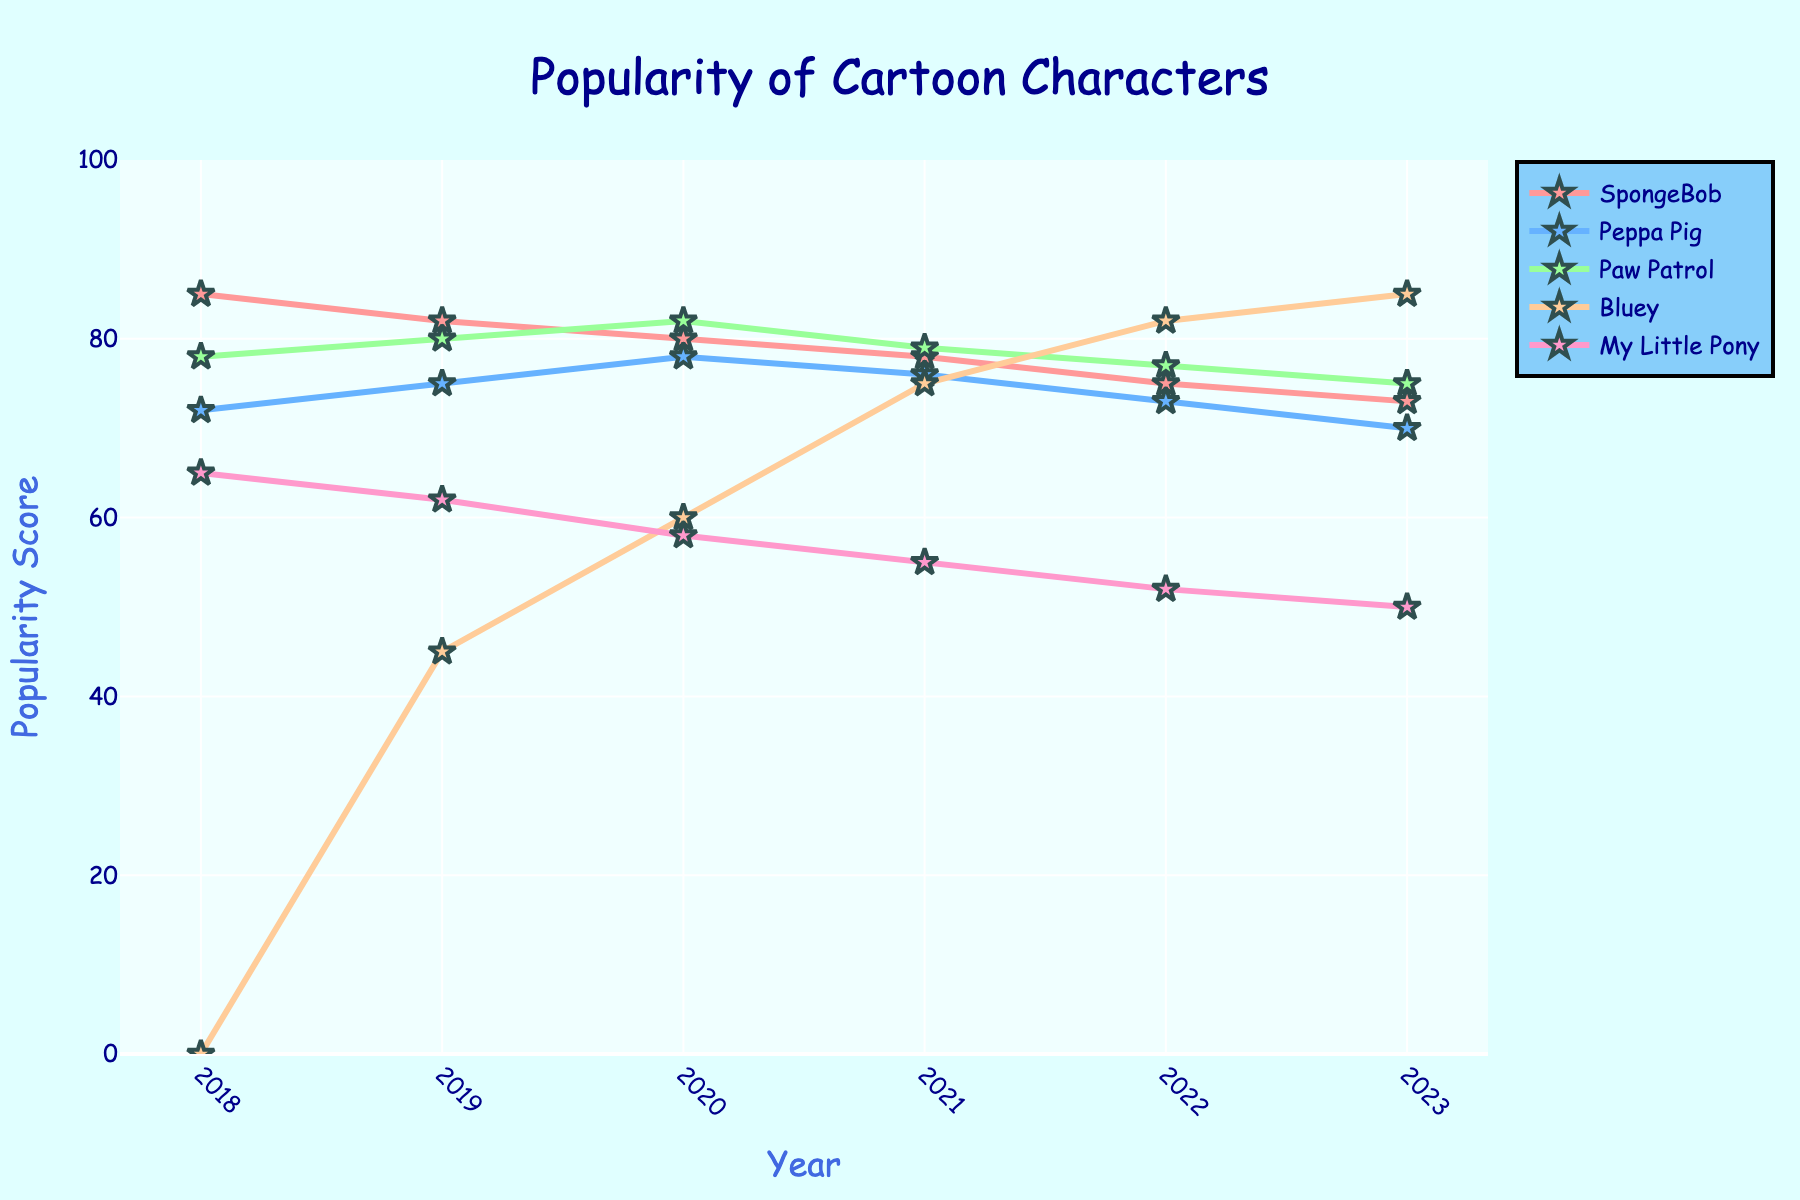What is the most popular cartoon character in 2023? Look at the data points for the year 2023 across all characters. The highest popularity score for 2023 is for Bluey, with a score of 85.
Answer: Bluey Which cartoon character has the largest decrease in popularity from 2018 to 2023? Calculate the difference in popularity scores between 2018 and 2023 for each character: SpongeBob (85 to 73, decrease of 12), Peppa Pig (72 to 70, decrease of 2), Paw Patrol (78 to 75, decrease of 3), Bluey (0 to 85, increase of 85), My Little Pony (65 to 50, decrease of 15). The largest decrease is for My Little Pony.
Answer: My Little Pony What is the trend observed for Bluey's popularity from 2018 to 2023? Since Bluey's popularity score starts at 0 in 2018 and increases consistently up to 85 in 2023, it shows a rising trend.
Answer: Rising trend In which year did SpongeBob and Paw Patrol have the closest popularity scores? Compare the differences in popularity scores for each year. In 2022, SpongeBob has a score of 75 and Paw Patrol has 77, with the smallest difference of 2.
Answer: 2022 Describe the change in popularity for My Little Pony between 2020 and 2023. The popularity score for My Little Pony decreased from 58 in 2020 to 50 in 2023.
Answer: Decreased Out of all the characters, which one has the second highest popularity in 2020? Identify the popularity scores for 2020 and find the second highest: SpongeBob (80), Peppa Pig (78), Paw Patrol (82), Bluey (60), My Little Pony (58). The second highest score is 80 for SpongeBob.
Answer: SpongeBob Which cartoon character shows the least variation in popularity over the years? Calculate the range (maximum score - minimum score) for each character. SpongeBob (85-73 = 12), Peppa Pig (78-70 = 8), Paw Patrol (82-75 = 7), Bluey (85-0 = 85), My Little Pony (65-50 = 15). Paw Patrol has the least variation with a range of 7.
Answer: Paw Patrol Between 2018 and 2019, which cartoon character experienced the largest increase in popularity? Calculate the difference in popularity scores between 2018 and 2019 for each character: SpongeBob (85 to 82, decrease of 3), Peppa Pig (72 to 75, increase of 3), Paw Patrol (78 to 80, increase of 2), Bluey (0 to 45, increase of 45), My Little Pony (65 to 62, decrease of 3). Bluey experienced the largest increase.
Answer: Bluey 